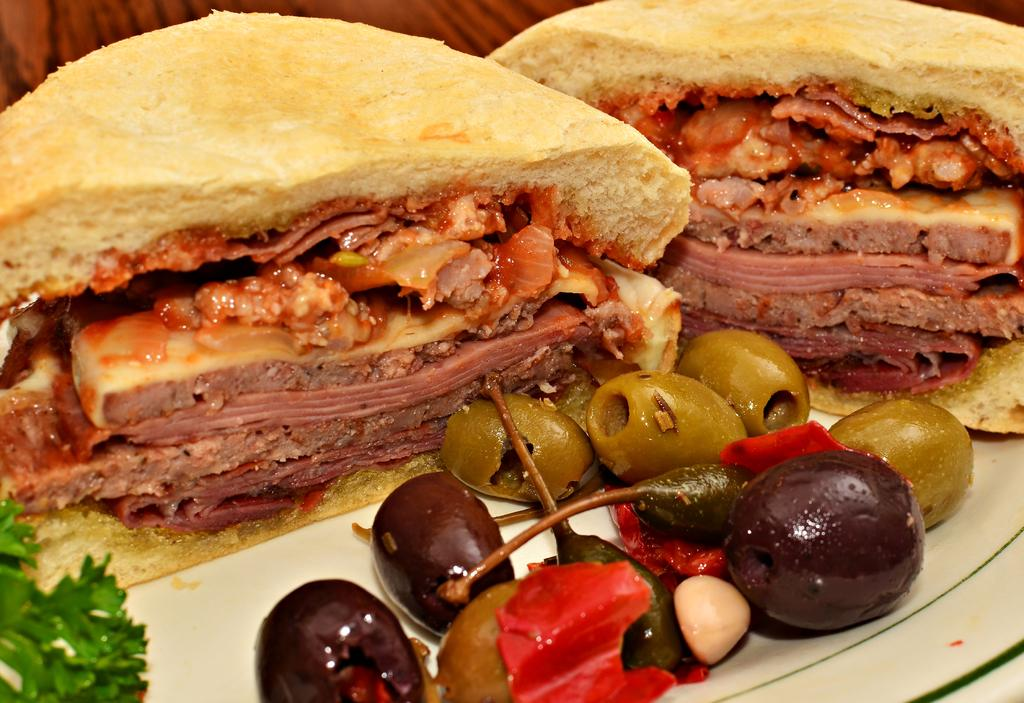What is present on the plate in the image? There is food in a plate in the image. What type of brain is visible in the image? There is no brain present in the image; it features a plate of food. Can you tell me which expert is responsible for preparing the food in the image? There is no information about the preparation of the food or any experts involved in the image. 